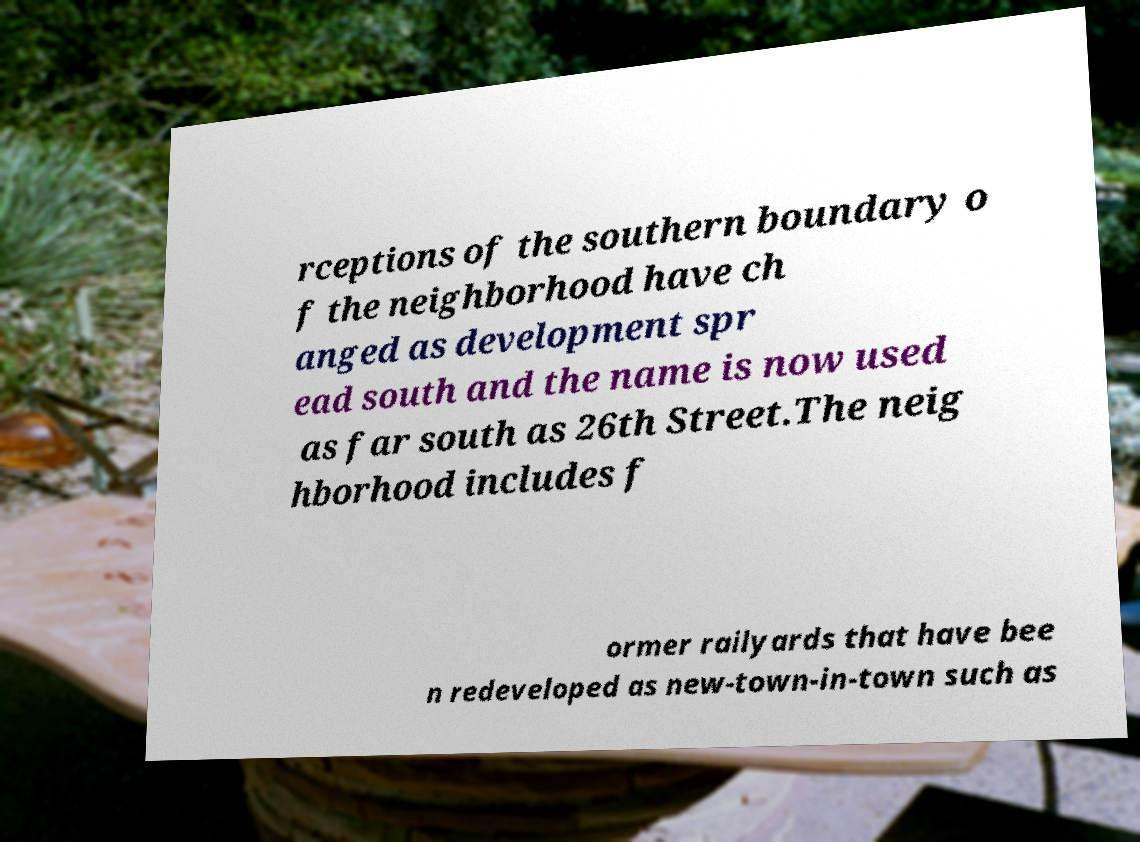Can you accurately transcribe the text from the provided image for me? rceptions of the southern boundary o f the neighborhood have ch anged as development spr ead south and the name is now used as far south as 26th Street.The neig hborhood includes f ormer railyards that have bee n redeveloped as new-town-in-town such as 